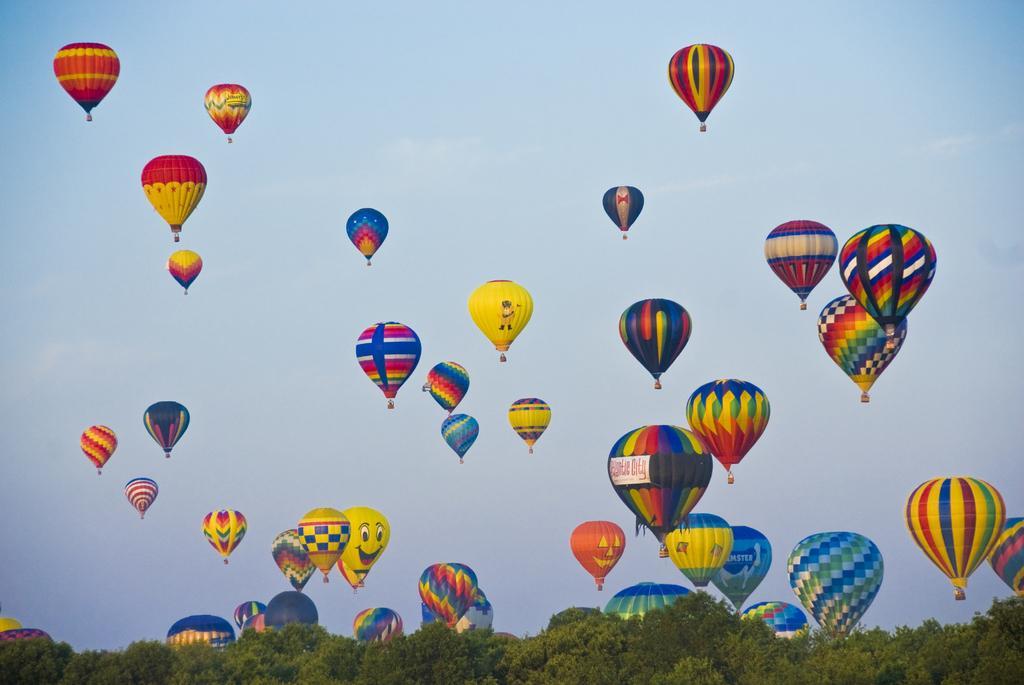How would you summarize this image in a sentence or two? This picture is clicked outside the city. In the foreground we can see the objects seems to be the trees. In the center we can see the group of parachutes of different colors are flying in the sky. 